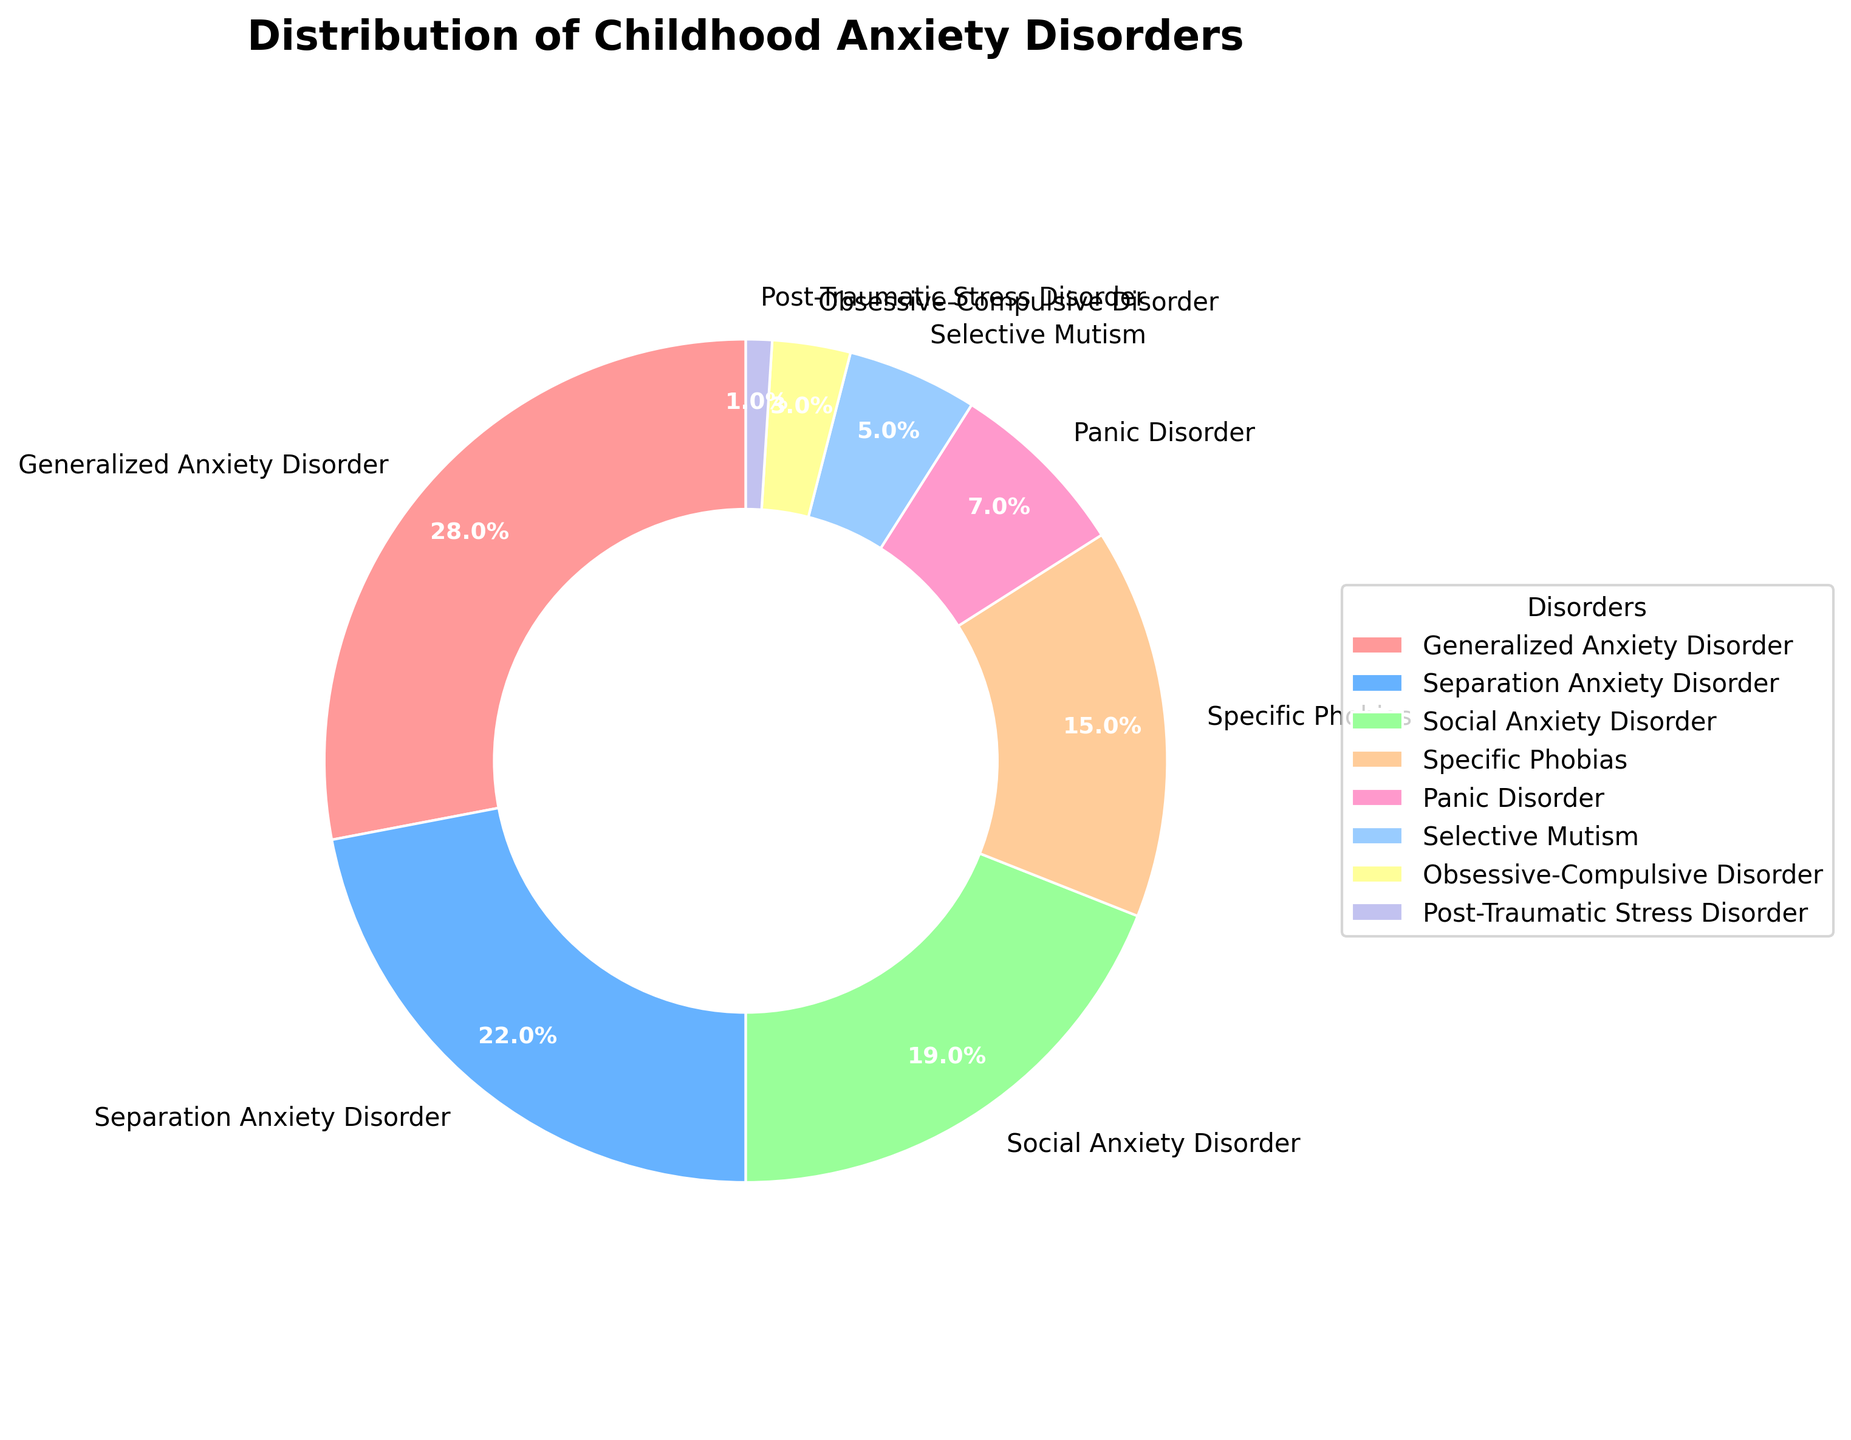What percentage of patients are diagnosed with Generalized Anxiety Disorder? The pie chart shows that the segment labeled "Generalized Anxiety Disorder" accounts for 28% of the total.
Answer: 28% Which disorder has the second highest percentage of patients? By examining the pie chart, the slice for Separation Anxiety Disorder (22%) is the second largest after Generalized Anxiety Disorder (28%).
Answer: Separation Anxiety Disorder What is the combined percentage of patients with Specific Phobias and Panic Disorder? Adding the percentage for Specific Phobias (15%) and Panic Disorder (7%), the combined percentage is 22%.
Answer: 22% How much larger is the percentage of patients with Social Anxiety Disorder compared to Selective Mutism? Social Anxiety Disorder accounts for 19% while Selective Mutism accounts for 5%. The difference is 19% - 5% = 14%.
Answer: 14% Name the disorder with the smallest percentage of patients and state that percentage. The smallest segment in the pie chart corresponds to Post-Traumatic Stress Disorder, which accounts for 1%.
Answer: Post-Traumatic Stress Disorder, 1% How many disorders have a percentage greater than or equal to 10%? By examining the pie chart, the disorders with percentages greater than or equal to 10% are Generalized Anxiety Disorder (28%), Separation Anxiety Disorder (22%), Social Anxiety Disorder (19%), and Specific Phobias (15%). There are 4 such disorders.
Answer: 4 What's the percentage of patients with disorders that have less than 5% representation? The disorders with less than 5% representation are Selective Mutism (5%), Obsessive-Compulsive Disorder (3%), and Post-Traumatic Stress Disorder (1%). Adding these, 5% + 3% + 1% = 9%.
Answer: 9% Which color represents Separation Anxiety Disorder in the pie chart? In the pie chart, the color corresponding to Separation Anxiety Disorder is light blue.
Answer: Light blue What percentage difference is there between the patients diagnosed with Social Anxiety Disorder and those with Generalized Anxiety Disorder? Generalized Anxiety Disorder makes up 28% while Social Anxiety Disorder is 19%. The difference is 28% - 19% = 9%.
Answer: 9% Which two disorders together constitute exactly half of the patient population? Generalized Anxiety Disorder (28%) and Separation Anxiety Disorder (22%) together add up to 28% + 22% = 50%.
Answer: Generalized Anxiety Disorder and Separation Anxiety Disorder 